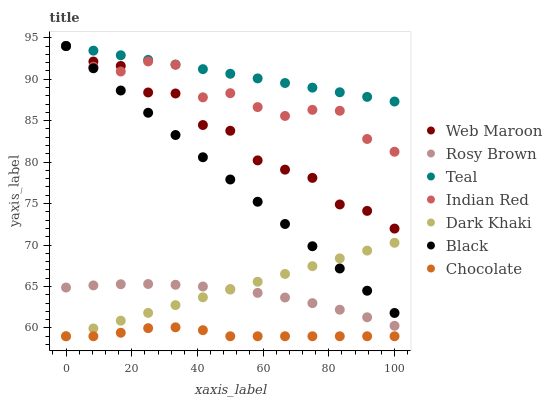Does Chocolate have the minimum area under the curve?
Answer yes or no. Yes. Does Teal have the maximum area under the curve?
Answer yes or no. Yes. Does Rosy Brown have the minimum area under the curve?
Answer yes or no. No. Does Rosy Brown have the maximum area under the curve?
Answer yes or no. No. Is Teal the smoothest?
Answer yes or no. Yes. Is Web Maroon the roughest?
Answer yes or no. Yes. Is Rosy Brown the smoothest?
Answer yes or no. No. Is Rosy Brown the roughest?
Answer yes or no. No. Does Chocolate have the lowest value?
Answer yes or no. Yes. Does Rosy Brown have the lowest value?
Answer yes or no. No. Does Indian Red have the highest value?
Answer yes or no. Yes. Does Rosy Brown have the highest value?
Answer yes or no. No. Is Chocolate less than Web Maroon?
Answer yes or no. Yes. Is Teal greater than Chocolate?
Answer yes or no. Yes. Does Black intersect Indian Red?
Answer yes or no. Yes. Is Black less than Indian Red?
Answer yes or no. No. Is Black greater than Indian Red?
Answer yes or no. No. Does Chocolate intersect Web Maroon?
Answer yes or no. No. 